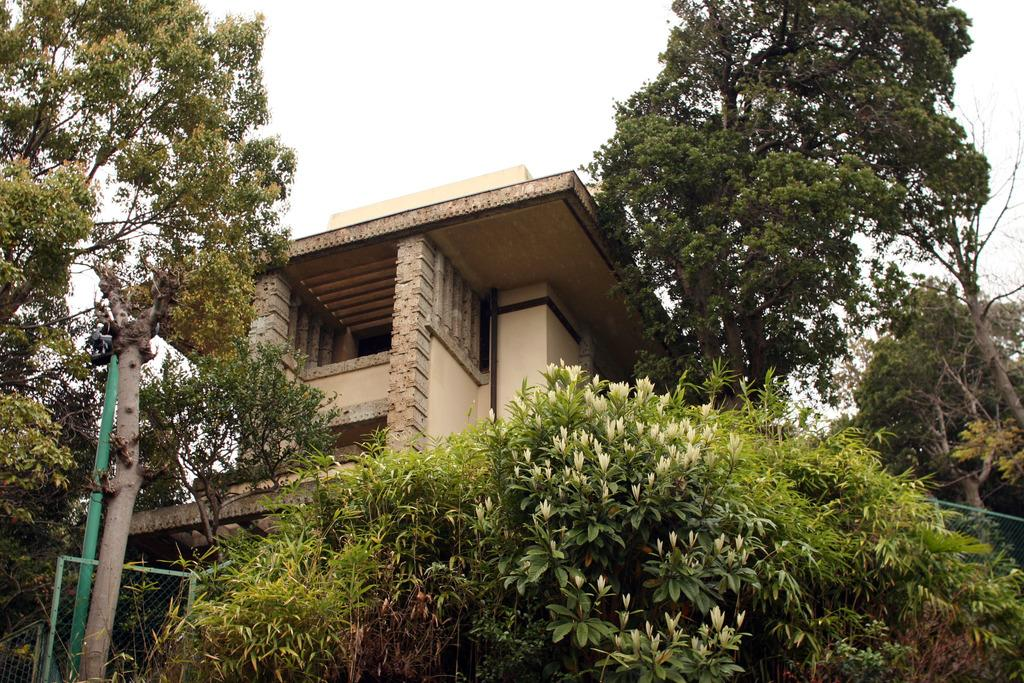What type of structure is visible in the image? There is a house in the image. What natural elements can be seen in the image? There are trees and plants in the image. What type of barrier is present in the image? There is a fence in the image. What is the color of the pole in the image? The pole in the image is green. What part of the natural environment is visible in the image? The sky is visible in the image. Can you see a shirt floating down the river in the image? There is no river or shirt present in the image. 